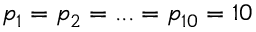<formula> <loc_0><loc_0><loc_500><loc_500>p _ { 1 } = p _ { 2 } = \dots = p _ { 1 0 } = 1 0</formula> 